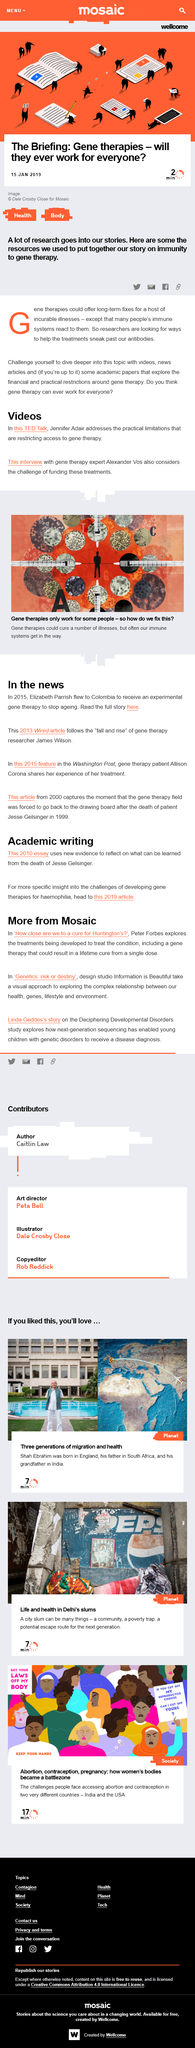Mention a couple of crucial points in this snapshot. Gene therapy has the potential to benefit individuals with incurable diseases by providing long-term solutions. The challenges and limitations of gene therapy and treatments have been addressed by experts Jennifer Adair and Alexander Vos. The news reported that Elizabeth Parrish was flying to Colombia. Gene therapy is a relatively new and still evolving field of medicine that involves the use of genes to treat or prevent diseases. The efficacy of gene therapy depends on the successful delivery of the therapeutic gene to the target cells. However, the use of genes as therapeutics can also result in immune reactions, which may limit the long-term success of gene therapy. The design studio featured in the documentary "Genetics: risk or destiny" is called "Information is Beautiful. 